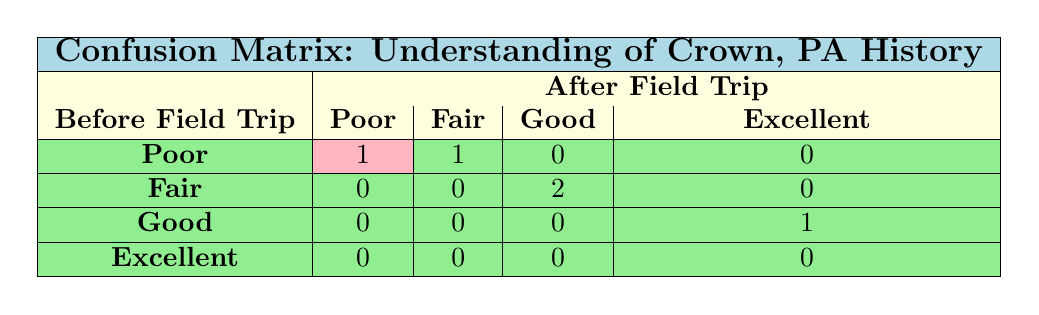What is the number of students who had a Poor understanding before the field trip? The table shows the category 'Poor' under 'Before Field Trip', which has a total of 2 students listed.
Answer: 2 How many students improved their understanding from Poor to Fair after the field trip? From the 'Poor' row in the 'Before Field Trip', 1 student improved to Fair after the field trip, as indicated in the 'Fair' column.
Answer: 1 What is the total number of students who had an Excellent understanding after the field trip? In the column labeled 'Excellent' under 'After Field Trip', only 2 students are listed, indicating the total number of students with Excellent understanding.
Answer: 2 Did any students remain in the Poor understanding category after the field trip? Looking at the 'Poor' row under 'After Field Trip', there are 0 students listed, indicating that none remained in Poor.
Answer: No What was the total count of students who had Fair understanding before and after the trip? The 'Before Field Trip' has 1 student under Fair category and the 'After Field Trip' also has 1 student, summing these gives a total of 2 students in 'Fair'.
Answer: 2 How many students increased their understanding level after the field trip? Going through the rows, 4 students improved their understanding levels: (1 from Poor to Fair), (1 from Fair to Good), and (1 from Good to Excellent), totaling 4 students.
Answer: 4 What proportion of students achieved an Excellent understanding after the field trip? Out of a total of 5 students, 2 achieved Excellent understanding. Therefore, the proportion is 2 out of 5, which equals 0.4 or 40%.
Answer: 40% How many students moved to Good understanding category after the trip? From the 'Good' category in 'After Field Trip', there are 3 students (2 moved from Fair, and 1 was originally Good), making the count clear.
Answer: 3 What are the total counts for each understanding category before the field trip? Summarizing each category from the 'Before Field Trip': Poor (2), Fair (1), Good (1), Excellent (1) gives totals of each category clearly outlined.
Answer: Poor: 2, Fair: 1, Good: 1, Excellent: 1 